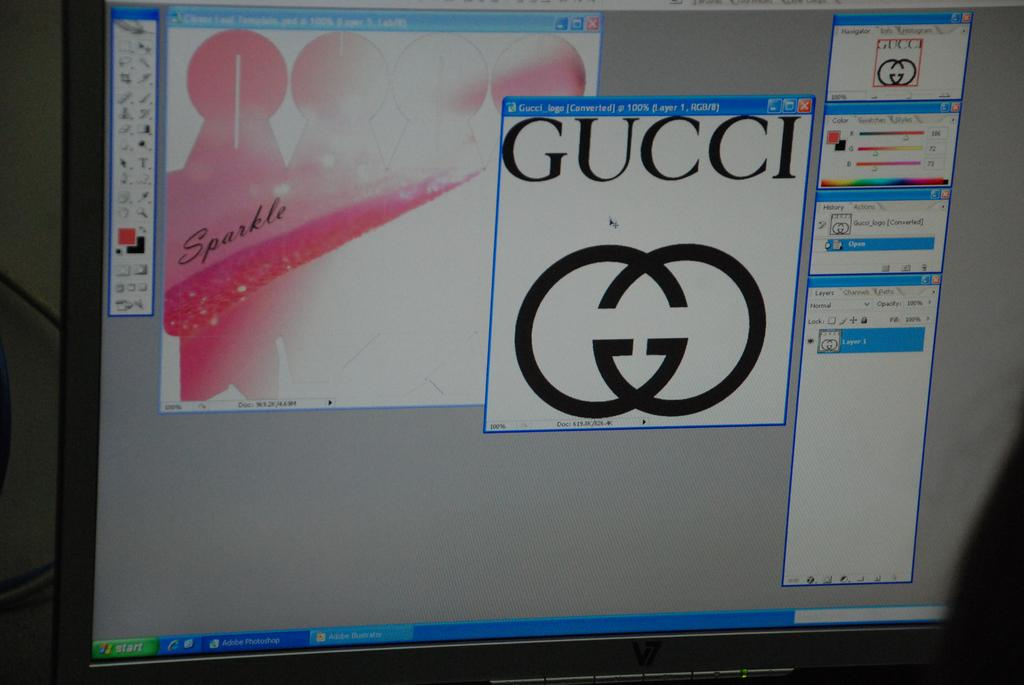Provide a one-sentence caption for the provided image. A computer screen shows the compnents of a Gucci advert in an image editor. 